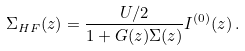Convert formula to latex. <formula><loc_0><loc_0><loc_500><loc_500>\Sigma _ { H F } ( z ) = \frac { U / 2 } { 1 + G ( z ) \Sigma ( z ) } I ^ { ( 0 ) } ( z ) \, .</formula> 